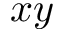Convert formula to latex. <formula><loc_0><loc_0><loc_500><loc_500>x y</formula> 